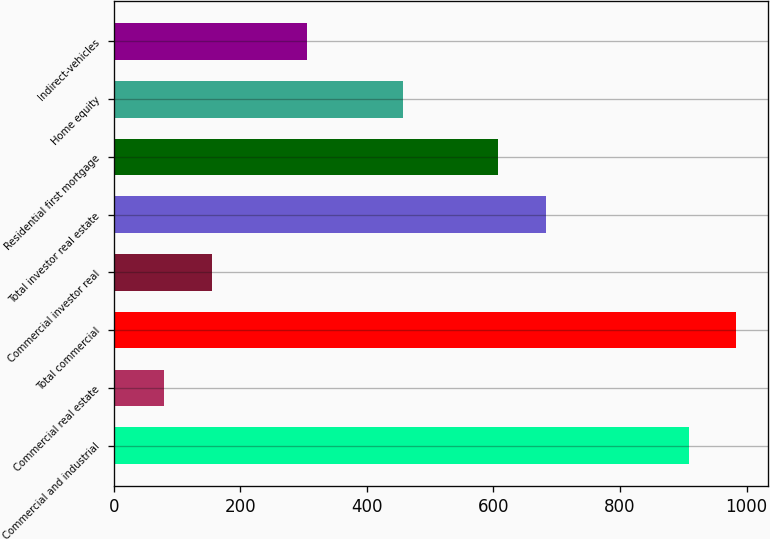Convert chart to OTSL. <chart><loc_0><loc_0><loc_500><loc_500><bar_chart><fcel>Commercial and industrial<fcel>Commercial real estate<fcel>Total commercial<fcel>Commercial investor real<fcel>Total investor real estate<fcel>Residential first mortgage<fcel>Home equity<fcel>Indirect-vehicles<nl><fcel>908.6<fcel>80.3<fcel>983.9<fcel>155.6<fcel>682.7<fcel>607.4<fcel>456.8<fcel>306.2<nl></chart> 